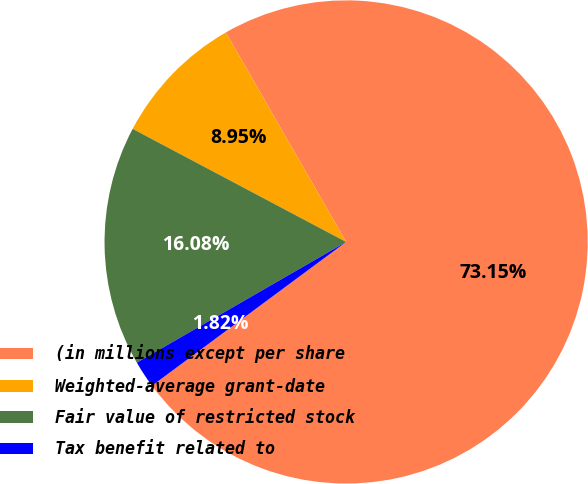Convert chart. <chart><loc_0><loc_0><loc_500><loc_500><pie_chart><fcel>(in millions except per share<fcel>Weighted-average grant-date<fcel>Fair value of restricted stock<fcel>Tax benefit related to<nl><fcel>73.15%<fcel>8.95%<fcel>16.08%<fcel>1.82%<nl></chart> 